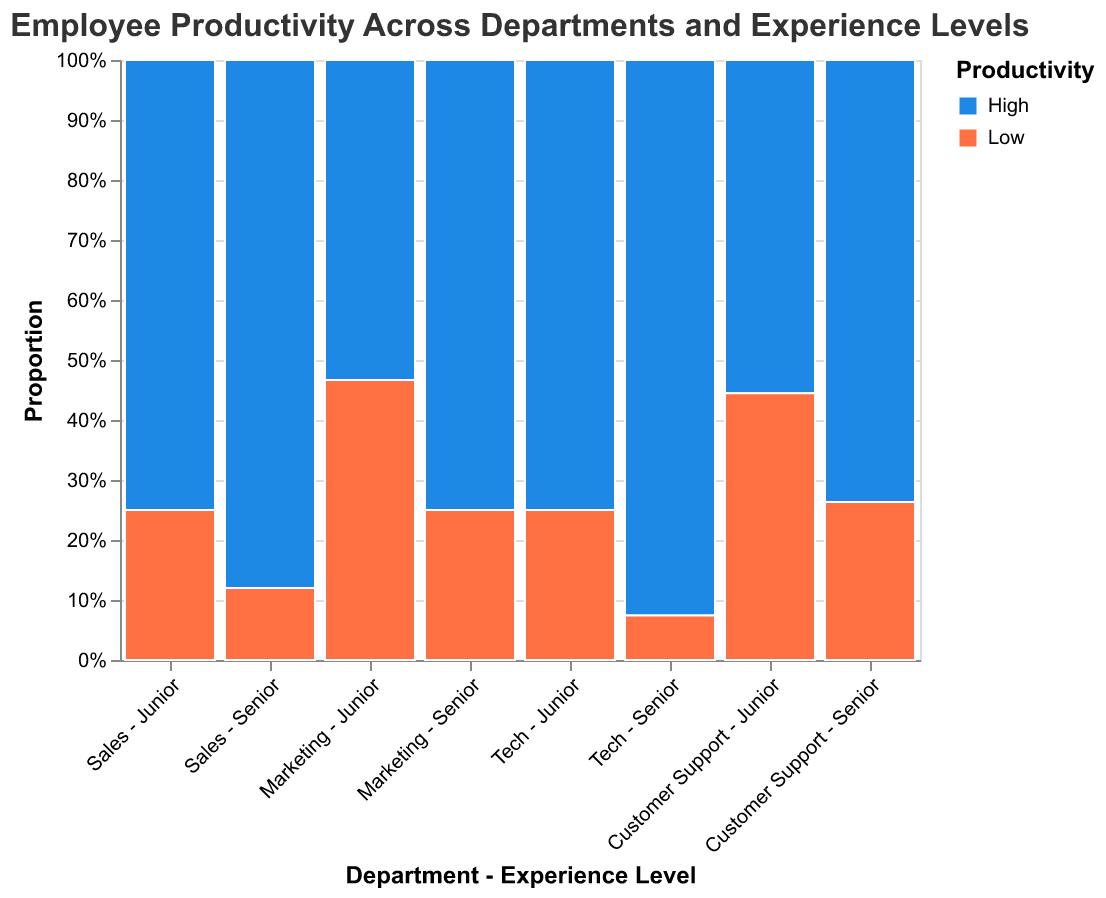What's the title of the figure? The title is located at the top of the plot, written in a larger font size than the other text.
Answer: Employee Productivity Across Departments and Experience Levels Which department has the highest proportion of high productivity for senior employees? To determine this, look at the normalized bars for each department and experience level, focusing on the senior level. Compare the proportions of the high productivity section (usually colored in blue).
Answer: Tech Which experience level has a higher proportion of low productivity employees in the Marketing department? By comparing the segments within the Marketing department, you need to observe the size of the low productivity sections for both junior and senior levels and determine which is larger.
Answer: Junior Is there any department where low productivity is higher than high productivity in both junior and senior experience levels? Evaluate each department's bars for both junior and senior levels, looking for more low productivity (usually colored in orange) than high productivity sections, and see if it applies to both levels.
Answer: No Which group (combination of department and experience level) has the lowest count of low productivity employees? Identify the group with the smallest segment of the low productivity section across all combinations shown in the plot. The smallest count can be found by comparing the segment sizes.
Answer: Tech - Senior Compare the proportion of high productivity employees in the junior experience level between Sales and Customer Support. Which one is higher? Look at the high productivity segments for the junior level in both Sales and Customer Support, and compare their relative sizes.
Answer: Sales How does the proportion of high productivity employees in the Tech department's junior level compare to its senior level? Compare the high productivity segments within the Tech department between the junior and senior levels. This involves observing the sizes of the segments and determining which one is larger.
Answer: Lower What is the combined proportion of low productivity employees in the Customer Support department for both junior and senior levels? Add the proportions of low productivity for both junior and senior levels within the Customer Support department. This requires calculating the combined size of the orange segments for both levels.
Answer: 38.5% Which department has a closer proportion of high productivity employees between junior and senior levels? Examine the high productivity (blue) segments for junior and senior levels within each department, and determine which department has the most similar segment sizes.
Answer: Marketing 